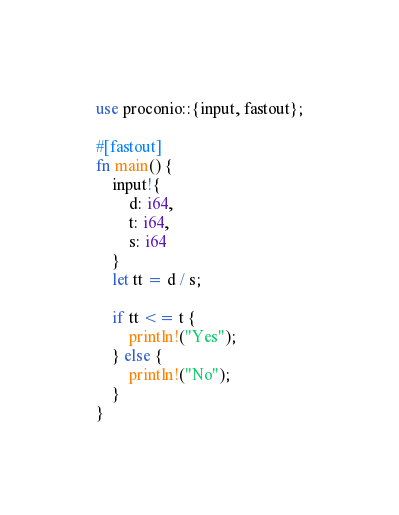Convert code to text. <code><loc_0><loc_0><loc_500><loc_500><_Rust_>use proconio::{input, fastout};

#[fastout]
fn main() {
    input!{
        d: i64,
        t: i64,
        s: i64
    }
    let tt = d / s;

    if tt <= t {
        println!("Yes");
    } else {
        println!("No");
    }
}
</code> 